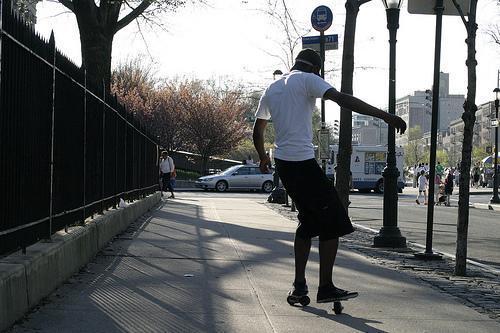How many men in white shirts are there?
Give a very brief answer. 1. 